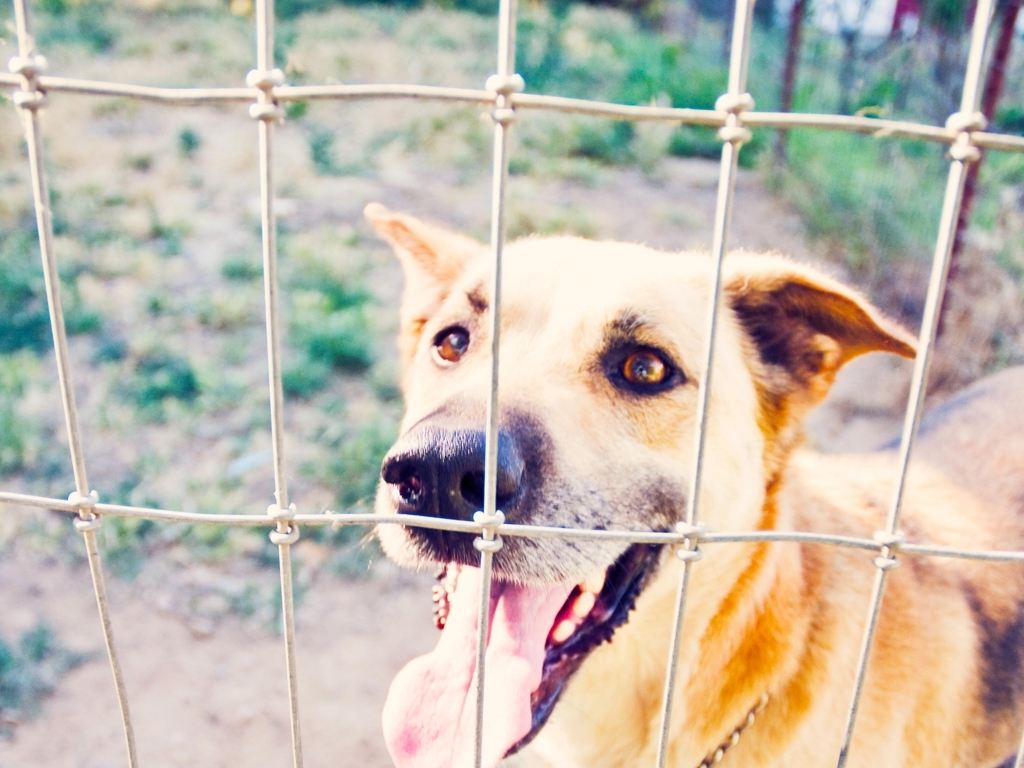Can you tell me more about the symbolism of the fence in this context? The fence in the foreground acts as a powerful symbol in this image. It represents a barrier, possibly indicating restriction or confinement that the dog is experiencing. The fence can invoke thoughts about domestic animals' need for freedom and space, and it might also provoke a discussion on responsible pet ownership and animal welfare. 